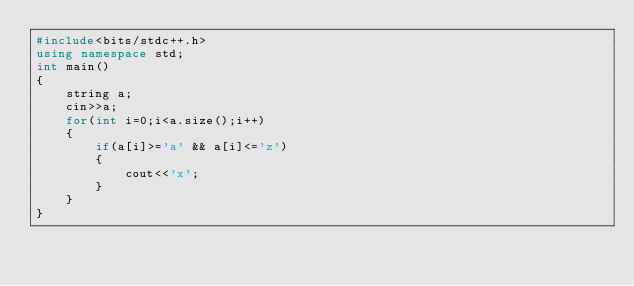Convert code to text. <code><loc_0><loc_0><loc_500><loc_500><_C++_>#include<bits/stdc++.h>
using namespace std;
int main()
{
    string a;
    cin>>a;
    for(int i=0;i<a.size();i++)
    {
        if(a[i]>='a' && a[i]<='z')
        {
            cout<<'x';
        }
    }
}
</code> 